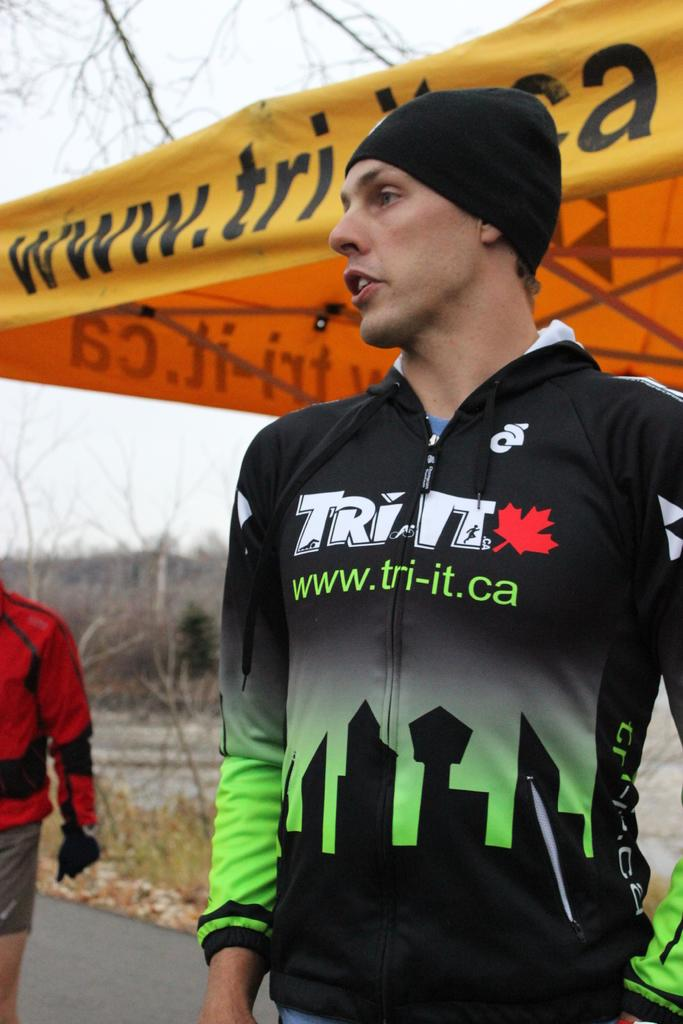<image>
Describe the image concisely. A man in athletic gears reading Tri-It stands waiting to compete in a race. 